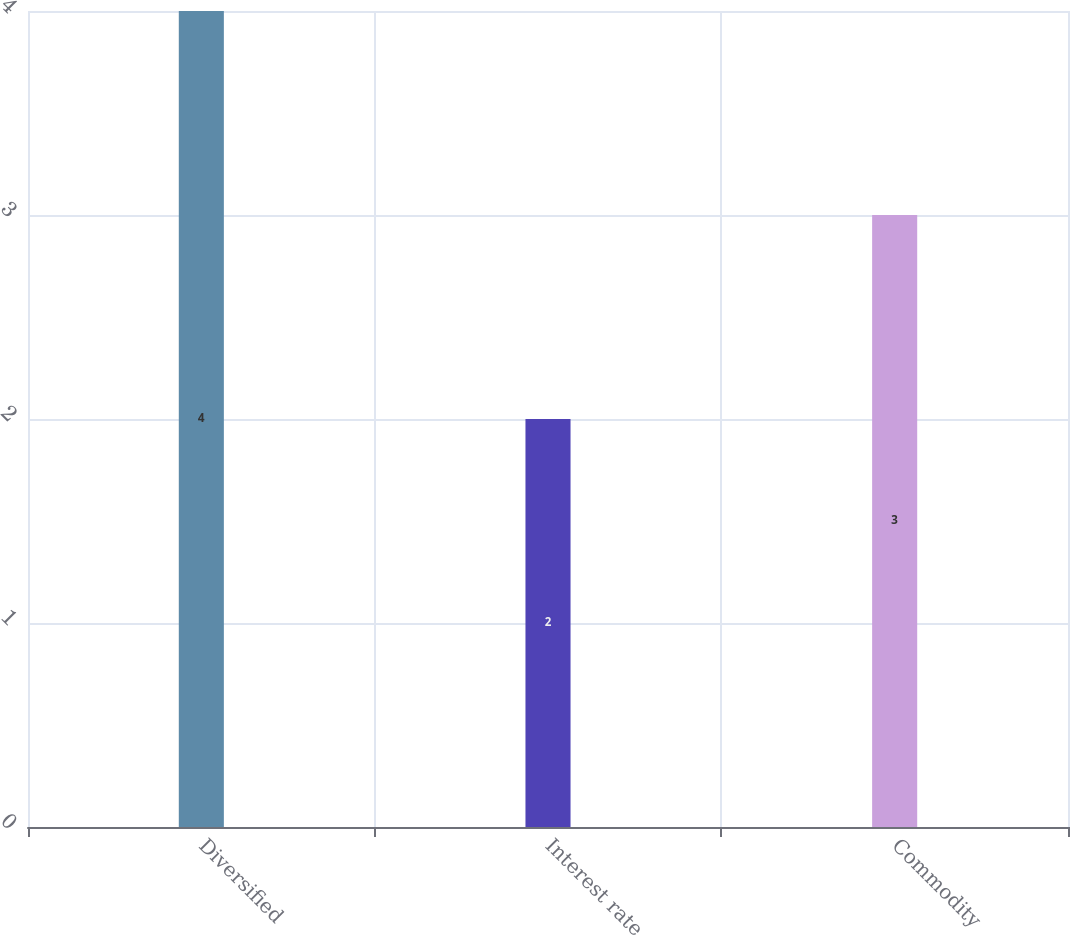Convert chart to OTSL. <chart><loc_0><loc_0><loc_500><loc_500><bar_chart><fcel>Diversified<fcel>Interest rate<fcel>Commodity<nl><fcel>4<fcel>2<fcel>3<nl></chart> 